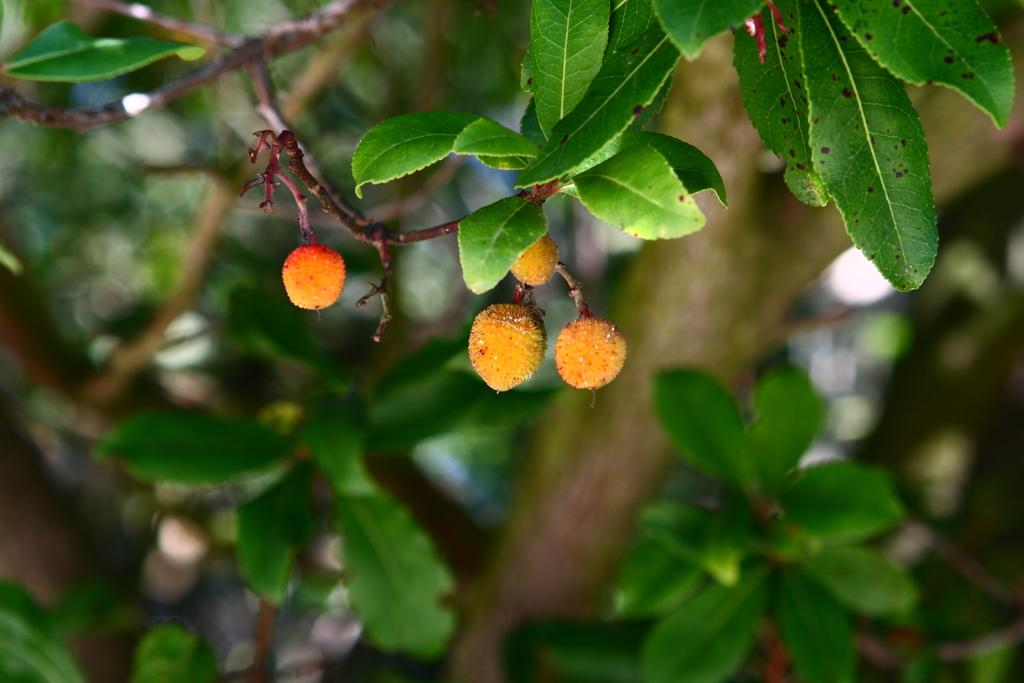What is present in the image? There is a tree in the image. What can be observed about the tree's appearance? The tree has green leaves. Can you describe the leaves in more detail? The leaves may resemble cherries. What type of pleasure can be seen enjoying a ride in the car in the image? There is no car or pleasure present in the image; it only features a tree with leaves that may resemble cherries. 